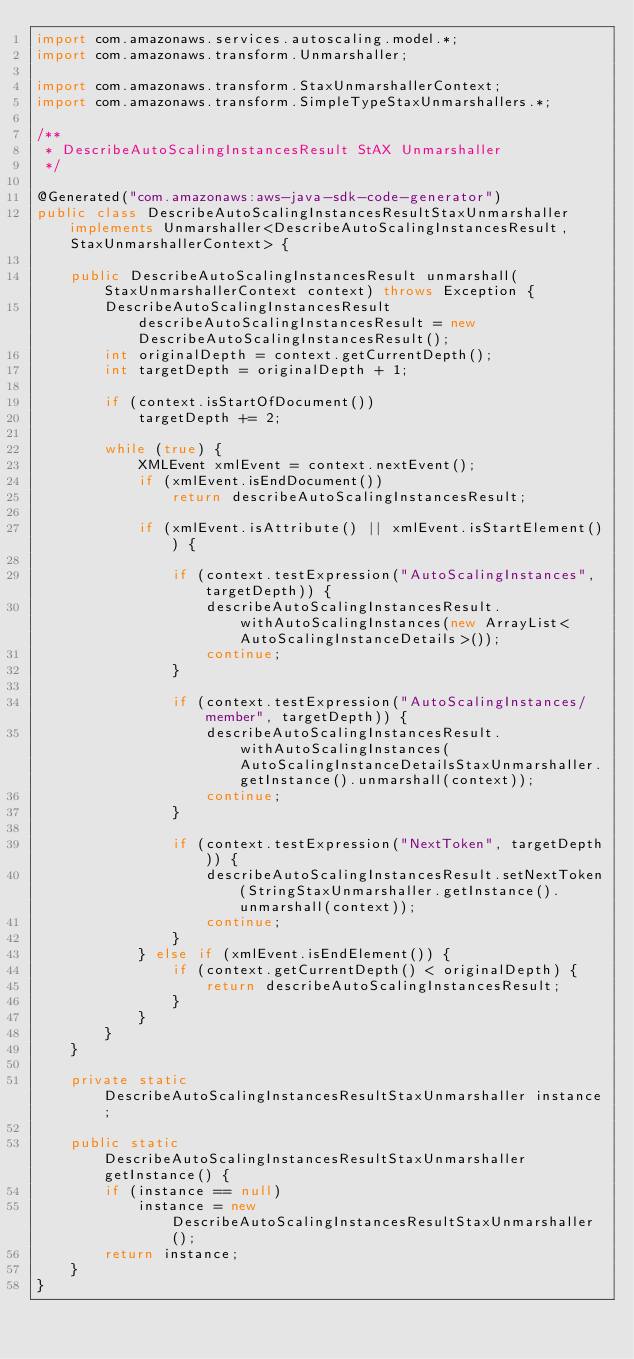Convert code to text. <code><loc_0><loc_0><loc_500><loc_500><_Java_>import com.amazonaws.services.autoscaling.model.*;
import com.amazonaws.transform.Unmarshaller;

import com.amazonaws.transform.StaxUnmarshallerContext;
import com.amazonaws.transform.SimpleTypeStaxUnmarshallers.*;

/**
 * DescribeAutoScalingInstancesResult StAX Unmarshaller
 */

@Generated("com.amazonaws:aws-java-sdk-code-generator")
public class DescribeAutoScalingInstancesResultStaxUnmarshaller implements Unmarshaller<DescribeAutoScalingInstancesResult, StaxUnmarshallerContext> {

    public DescribeAutoScalingInstancesResult unmarshall(StaxUnmarshallerContext context) throws Exception {
        DescribeAutoScalingInstancesResult describeAutoScalingInstancesResult = new DescribeAutoScalingInstancesResult();
        int originalDepth = context.getCurrentDepth();
        int targetDepth = originalDepth + 1;

        if (context.isStartOfDocument())
            targetDepth += 2;

        while (true) {
            XMLEvent xmlEvent = context.nextEvent();
            if (xmlEvent.isEndDocument())
                return describeAutoScalingInstancesResult;

            if (xmlEvent.isAttribute() || xmlEvent.isStartElement()) {

                if (context.testExpression("AutoScalingInstances", targetDepth)) {
                    describeAutoScalingInstancesResult.withAutoScalingInstances(new ArrayList<AutoScalingInstanceDetails>());
                    continue;
                }

                if (context.testExpression("AutoScalingInstances/member", targetDepth)) {
                    describeAutoScalingInstancesResult.withAutoScalingInstances(AutoScalingInstanceDetailsStaxUnmarshaller.getInstance().unmarshall(context));
                    continue;
                }

                if (context.testExpression("NextToken", targetDepth)) {
                    describeAutoScalingInstancesResult.setNextToken(StringStaxUnmarshaller.getInstance().unmarshall(context));
                    continue;
                }
            } else if (xmlEvent.isEndElement()) {
                if (context.getCurrentDepth() < originalDepth) {
                    return describeAutoScalingInstancesResult;
                }
            }
        }
    }

    private static DescribeAutoScalingInstancesResultStaxUnmarshaller instance;

    public static DescribeAutoScalingInstancesResultStaxUnmarshaller getInstance() {
        if (instance == null)
            instance = new DescribeAutoScalingInstancesResultStaxUnmarshaller();
        return instance;
    }
}
</code> 